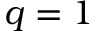<formula> <loc_0><loc_0><loc_500><loc_500>q = 1</formula> 